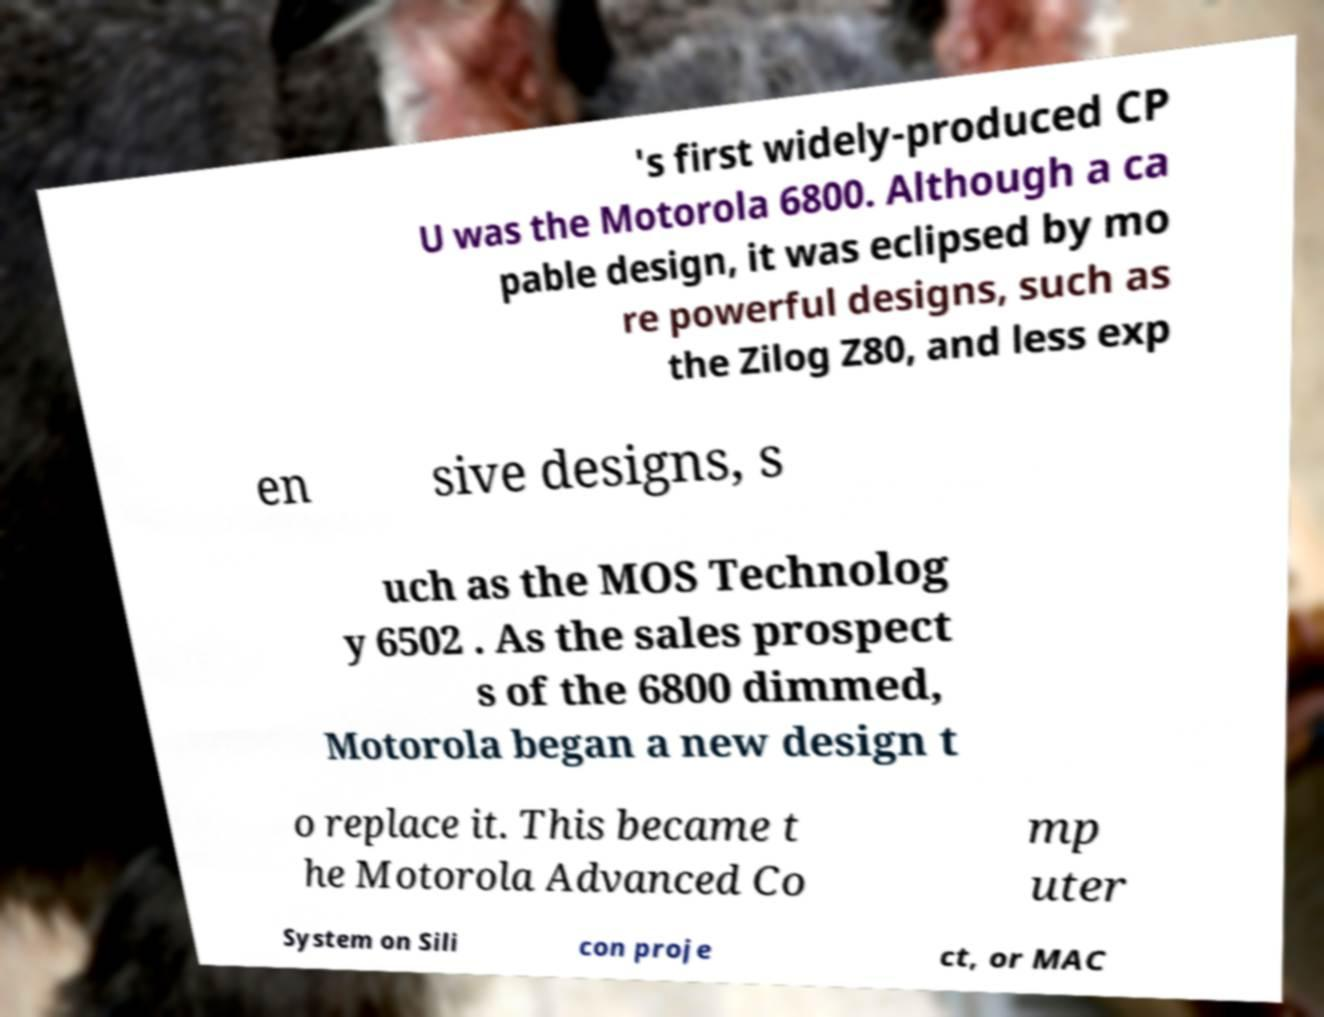What messages or text are displayed in this image? I need them in a readable, typed format. 's first widely-produced CP U was the Motorola 6800. Although a ca pable design, it was eclipsed by mo re powerful designs, such as the Zilog Z80, and less exp en sive designs, s uch as the MOS Technolog y 6502 . As the sales prospect s of the 6800 dimmed, Motorola began a new design t o replace it. This became t he Motorola Advanced Co mp uter System on Sili con proje ct, or MAC 